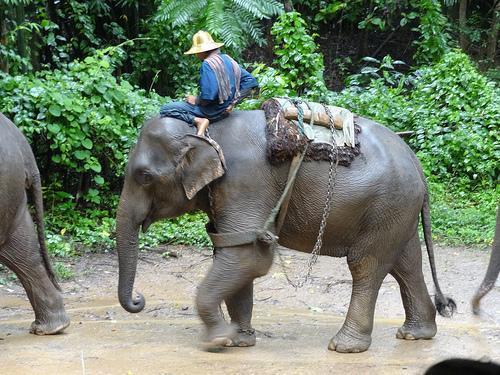How many elephant tails are visible?
Give a very brief answer. 2. How many men are riding elephants in this photo?
Give a very brief answer. 1. How many elephant feet are visible?
Give a very brief answer. 5. 